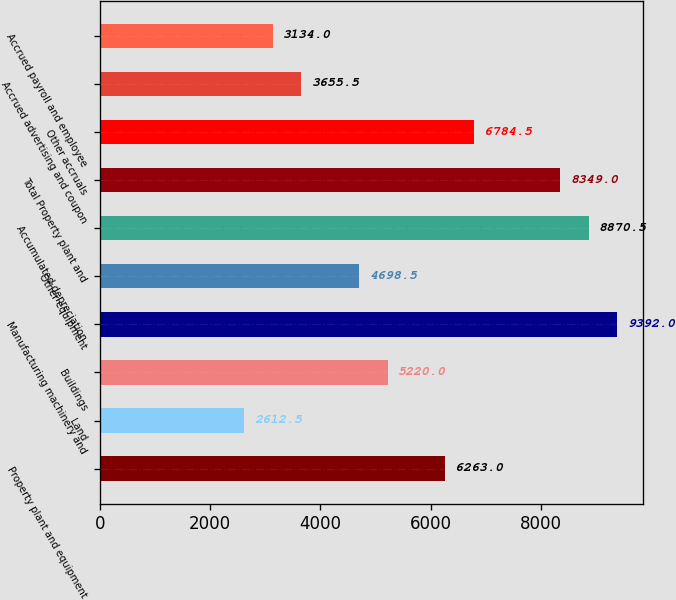Convert chart. <chart><loc_0><loc_0><loc_500><loc_500><bar_chart><fcel>Property plant and equipment<fcel>Land<fcel>Buildings<fcel>Manufacturing machinery and<fcel>Other equipment<fcel>Accumulated depreciation<fcel>Total Property plant and<fcel>Other accruals<fcel>Accrued advertising and coupon<fcel>Accrued payroll and employee<nl><fcel>6263<fcel>2612.5<fcel>5220<fcel>9392<fcel>4698.5<fcel>8870.5<fcel>8349<fcel>6784.5<fcel>3655.5<fcel>3134<nl></chart> 